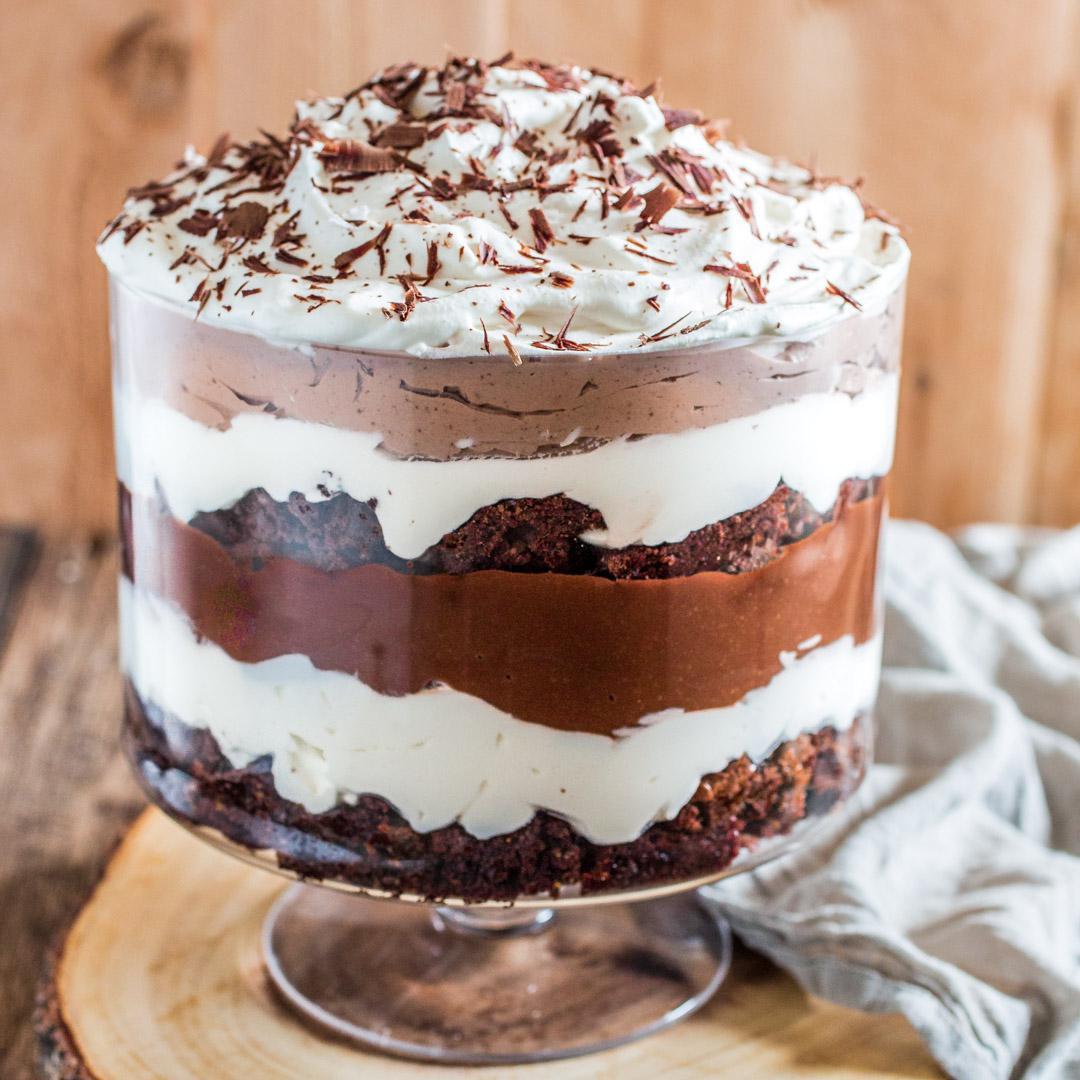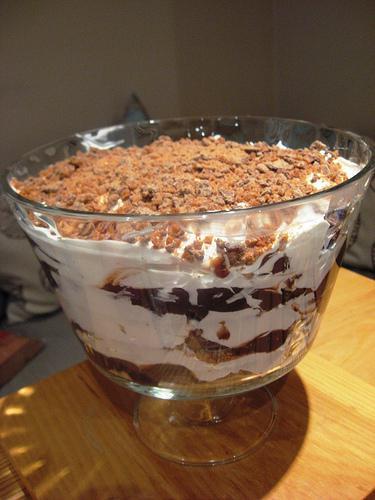The first image is the image on the left, the second image is the image on the right. For the images shown, is this caption "A round bowl with a lip are features in both images." true? Answer yes or no. No. The first image is the image on the left, the second image is the image on the right. For the images shown, is this caption "at least one trifle dessert has fruit on top" true? Answer yes or no. No. 